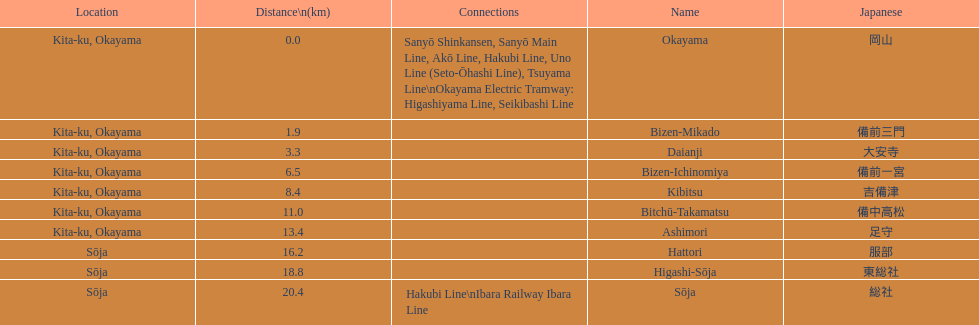What are the members of the kibi line? Okayama, Bizen-Mikado, Daianji, Bizen-Ichinomiya, Kibitsu, Bitchū-Takamatsu, Ashimori, Hattori, Higashi-Sōja, Sōja. Which of them have a distance of more than 1 km? Bizen-Mikado, Daianji, Bizen-Ichinomiya, Kibitsu, Bitchū-Takamatsu, Ashimori, Hattori, Higashi-Sōja, Sōja. Which of them have a distance of less than 2 km? Okayama, Bizen-Mikado. Which has a distance between 1 km and 2 km? Bizen-Mikado. 